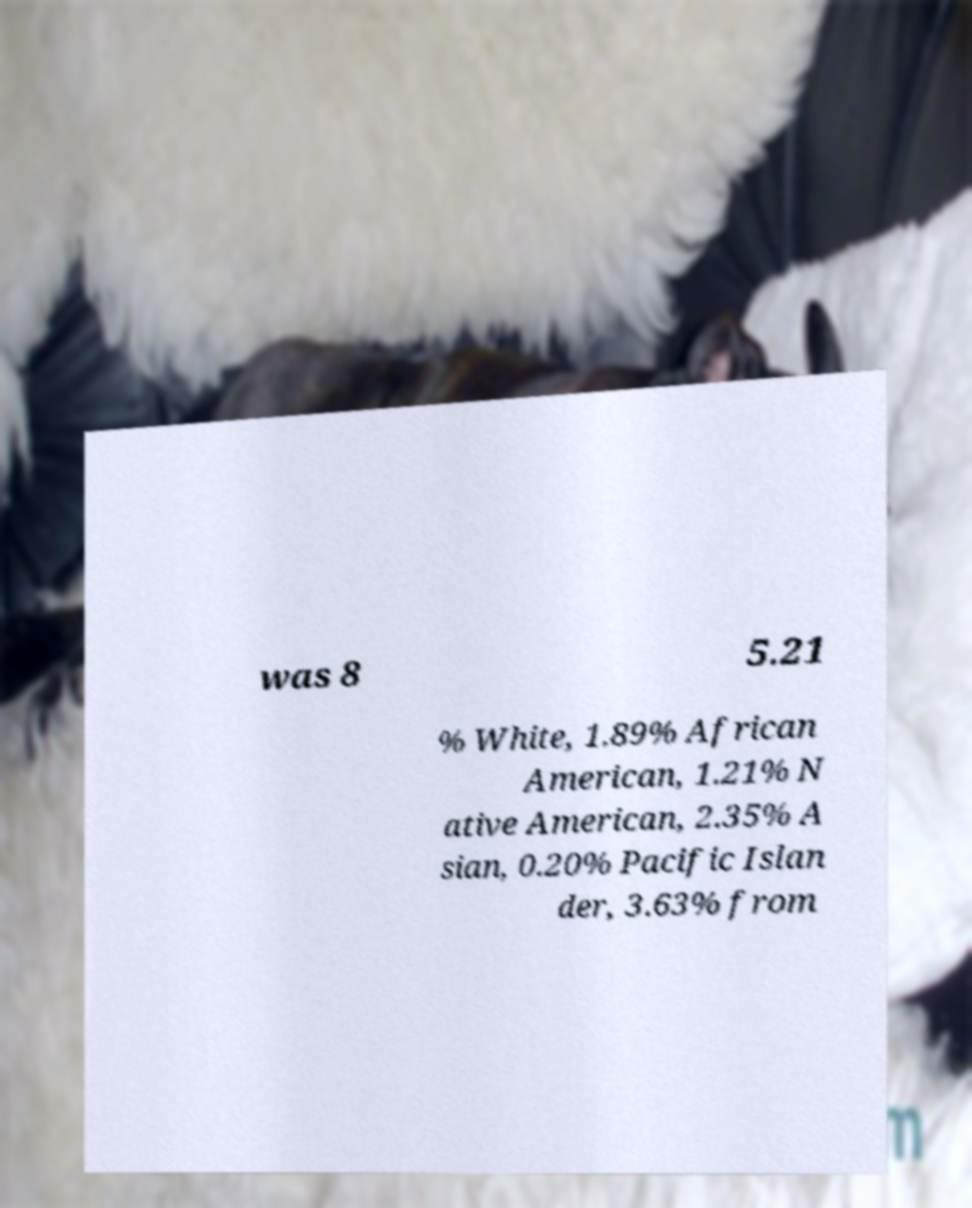For documentation purposes, I need the text within this image transcribed. Could you provide that? was 8 5.21 % White, 1.89% African American, 1.21% N ative American, 2.35% A sian, 0.20% Pacific Islan der, 3.63% from 